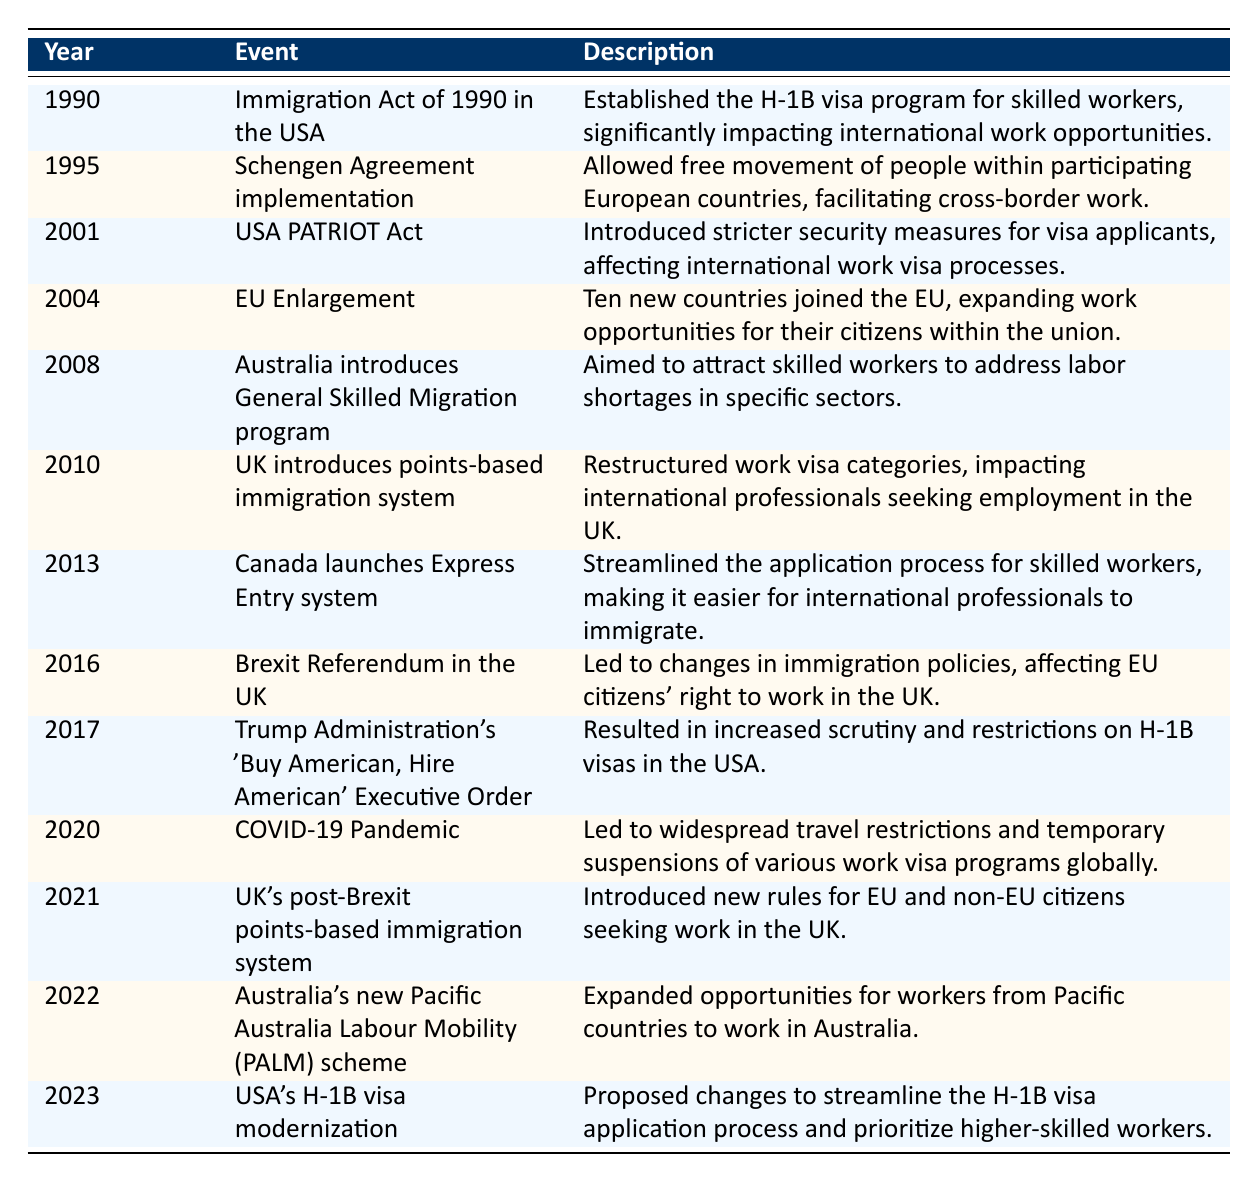What event established the H-1B visa program in the USA? The table indicates that the H-1B visa program was established by the Immigration Act of 1990, listed under the year 1990.
Answer: Immigration Act of 1990 in the USA In which year did the Schengen Agreement come into effect? According to the data, the Schengen Agreement was implemented in 1995, as noted in the row for that year.
Answer: 1995 True or False: The USA PATRIOT Act increased the number of international work visas available. The table states that the USA PATRIOT Act introduced stricter security measures, which implies a negative impact on the availability of work visas, not an increase.
Answer: False How many significant policy events related to international work visas occurred between 2010 and 2022? From the table, we can count the significant events from the year 2010 (UK's points-based immigration system) to 2022 (Australia's PALM scheme), which gives us a total of 5 events: 2010, 2013, 2016, 2021, and 2022.
Answer: 5 What were the two events that significantly changed immigration policy for the UK? The two events that notably changed immigration policy for the UK are the Brexit Referendum in 2016 and the UK's post-Brexit points-based immigration system in 2021, both listed in the table.
Answer: 2016 and 2021 How did the COVID-19 pandemic impact international work visa programs? The table notes that the COVID-19 pandemic in 2020 led to widespread travel restrictions and temporary suspensions of work visa programs globally, indicating a major negative impact.
Answer: Widespread travel restrictions and suspensions What is the latest event in the table related to international work visas? The latest event mentioned in the table is from the year 2023, which discusses the proposed changes to streamline the H-1B visa application process in the USA.
Answer: USA's H-1B visa modernization How did the introduction of the General Skilled Migration program in Australia impact labor shortages? The table describes the 2008 introduction of Australia's General Skilled Migration program as an initiative aimed to attract skilled workers to address labor shortages, indicating a direct connection between the program and labor market needs.
Answer: Attracted skilled workers to address labor shortages How many events in the table involved changes that specifically targeted EU citizens? The Brexit Referendum in 2016 and the UK's post-Brexit points-based immigration system in 2021 both pertain to changes affecting EU citizens, making a total of 2 events.
Answer: 2 